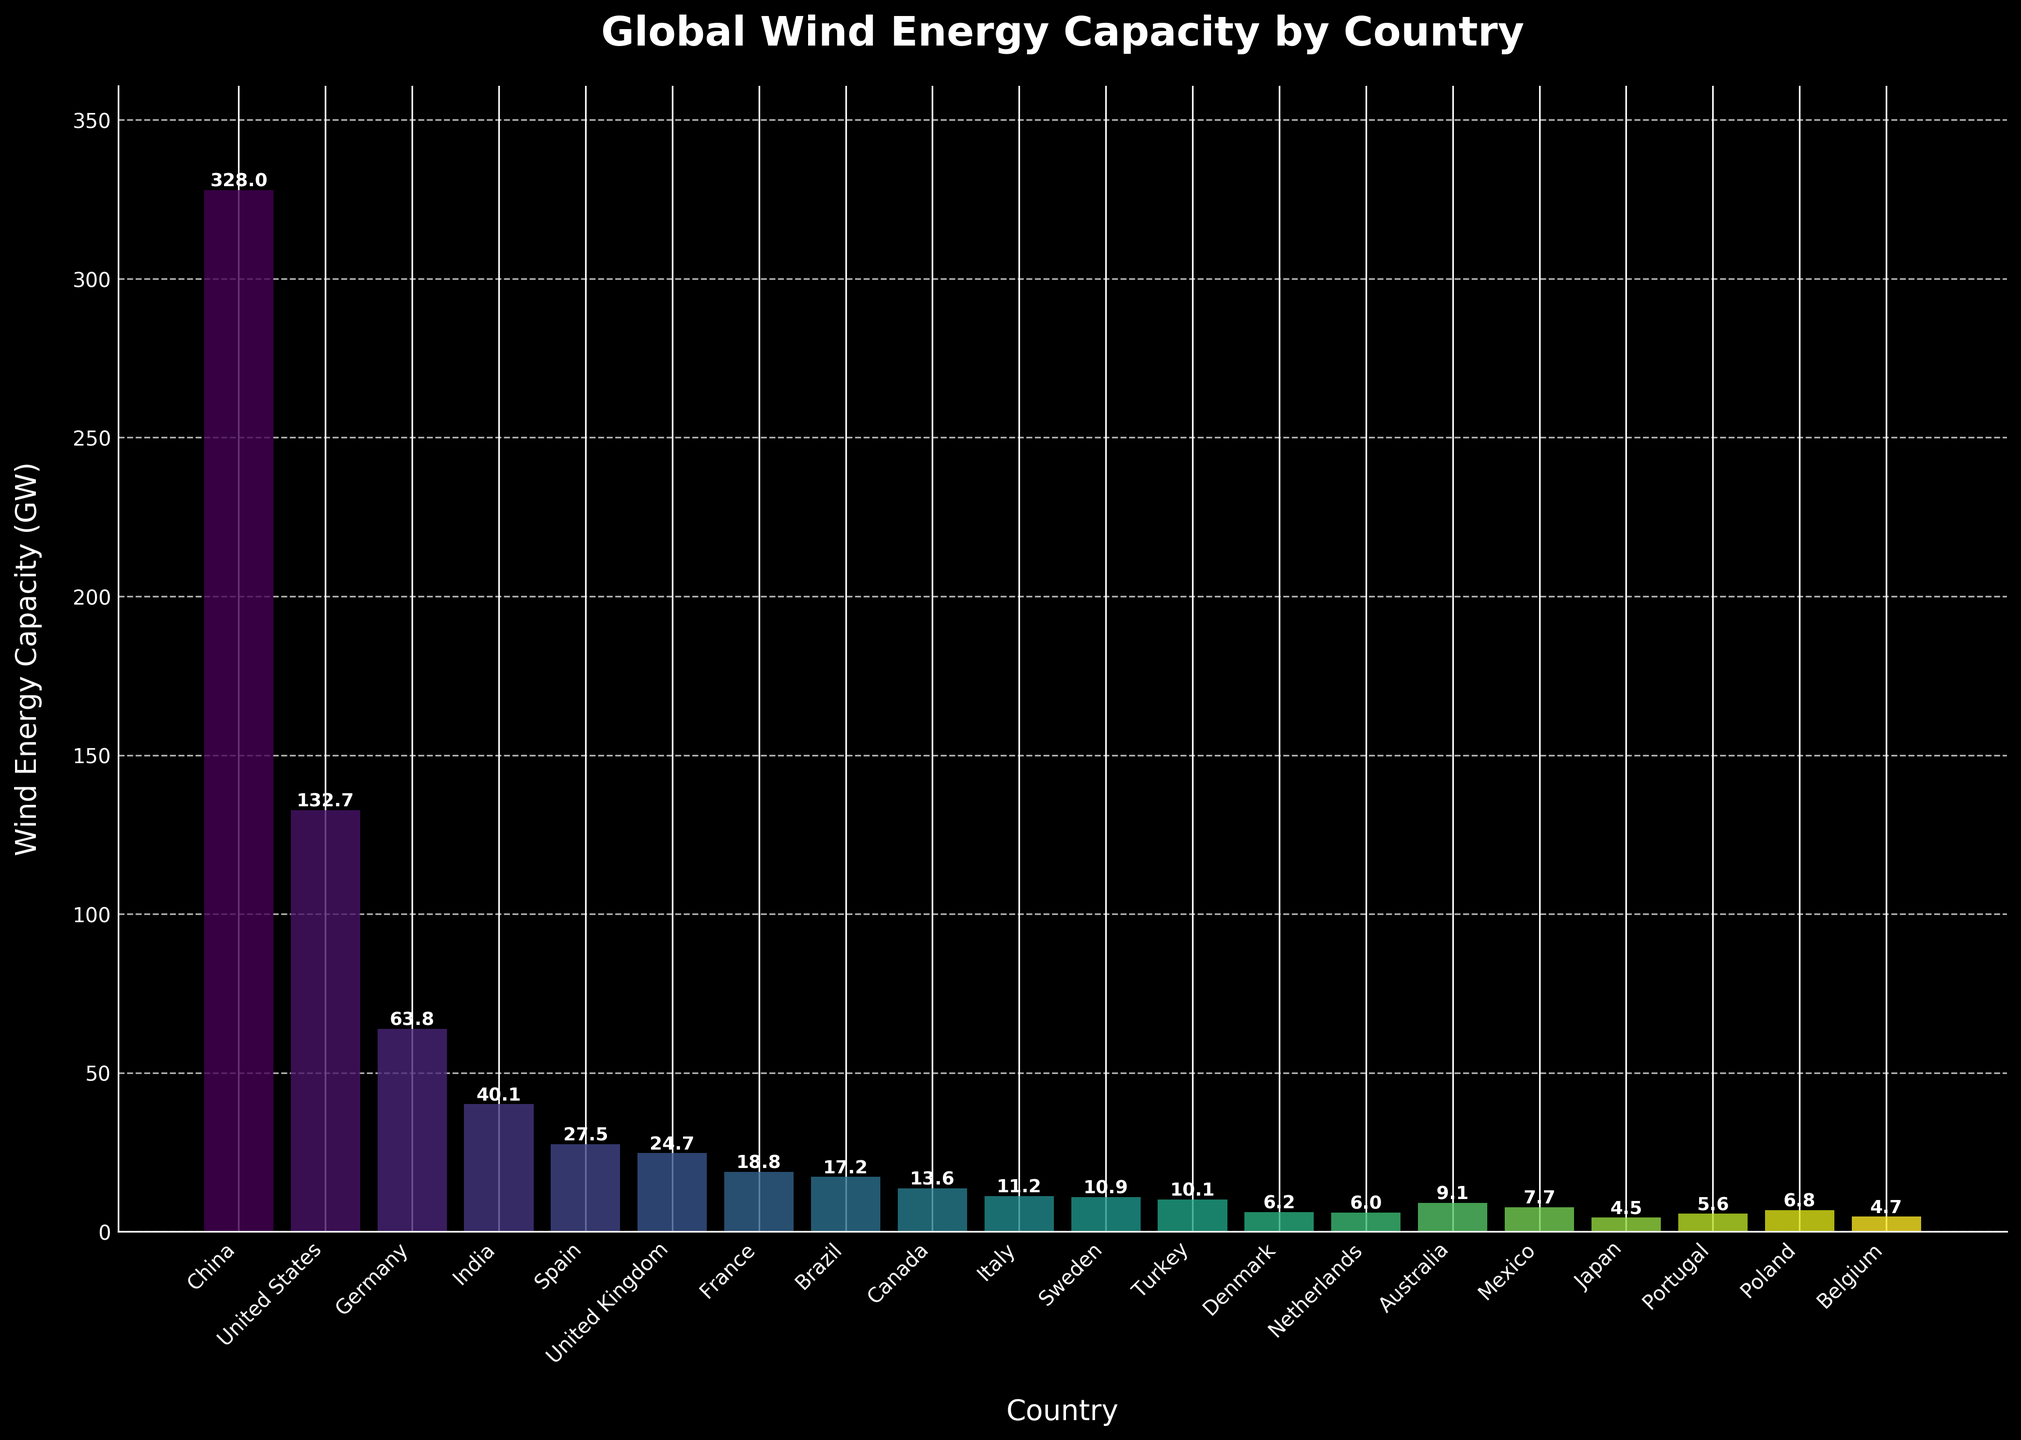Which country has the highest wind energy capacity? The figure shows the wind energy capacity for each country with China having the tallest bar, indicating the highest capacity.
Answer: China How much greater is the wind energy capacity of China compared to the United States? China has a capacity of 328.0 GW, and the United States has 132.7 GW. The difference is 328.0 - 132.7 = 195.3 GW.
Answer: 195.3 GW What is the combined wind energy capacity of Germany, India, and Spain? The capacities are: Germany (63.8 GW), India (40.1 GW), and Spain (27.5 GW). Summing these: 63.8 + 40.1 + 27.5 = 131.4 GW.
Answer: 131.4 GW Which country has a lower wind energy capacity, Italy or Sweden, and by how much? Italy has 11.2 GW while Sweden has 10.9 GW. The difference is 11.2 - 10.9 = 0.3 GW.
Answer: Sweden by 0.3 GW How does the wind energy capacity of Brazil compare to Canada and Mexico combined? Brazil has 17.2 GW. Canada and Mexico combined have 13.6 + 7.7 = 21.3 GW, which is greater than Brazil by 21.3 - 17.2 = 4.1 GW.
Answer: Canada and Mexico by 4.1 GW What is the average wind energy capacity of the top 5 countries? The top 5 countries are China (328.0 GW), United States (132.7 GW), Germany (63.8 GW), India (40.1 GW), and Spain (27.5 GW). The average is (328.0 + 132.7 + 63.8 + 40.1 + 27.5) / 5 = 118.42 GW.
Answer: 118.42 GW Which country among the listed has the lowest wind energy capacity and what is the value? Japan has the smallest bar, indicating the lowest capacity with 4.5 GW.
Answer: Japan with 4.5 GW How many countries have a wind energy capacity above 20 GW? By checking the bars above the 20 GW mark: China, United States, Germany, India, Spain, and United Kingdom. There are 6 countries.
Answer: 6 countries Compare the wind energy capacities of Turkey and Portugal. Which one is higher? Turkey has 10.1 GW and Portugal has 5.6 GW. Turkey has a higher capacity.
Answer: Turkey What is the total wind energy capacity for all the listed countries? Summing the capacities: 328.0 + 132.7 + 63.8 + 40.1 + 27.5 + 24.7 + 18.8 + 17.2 + 13.6 + 11.2 + 10.9 + 10.1 + 6.2 + 6.0 + 9.1 + 7.7 + 4.5 + 5.6 + 6.8 + 4.7 = 739.4 GW.
Answer: 739.4 GW 